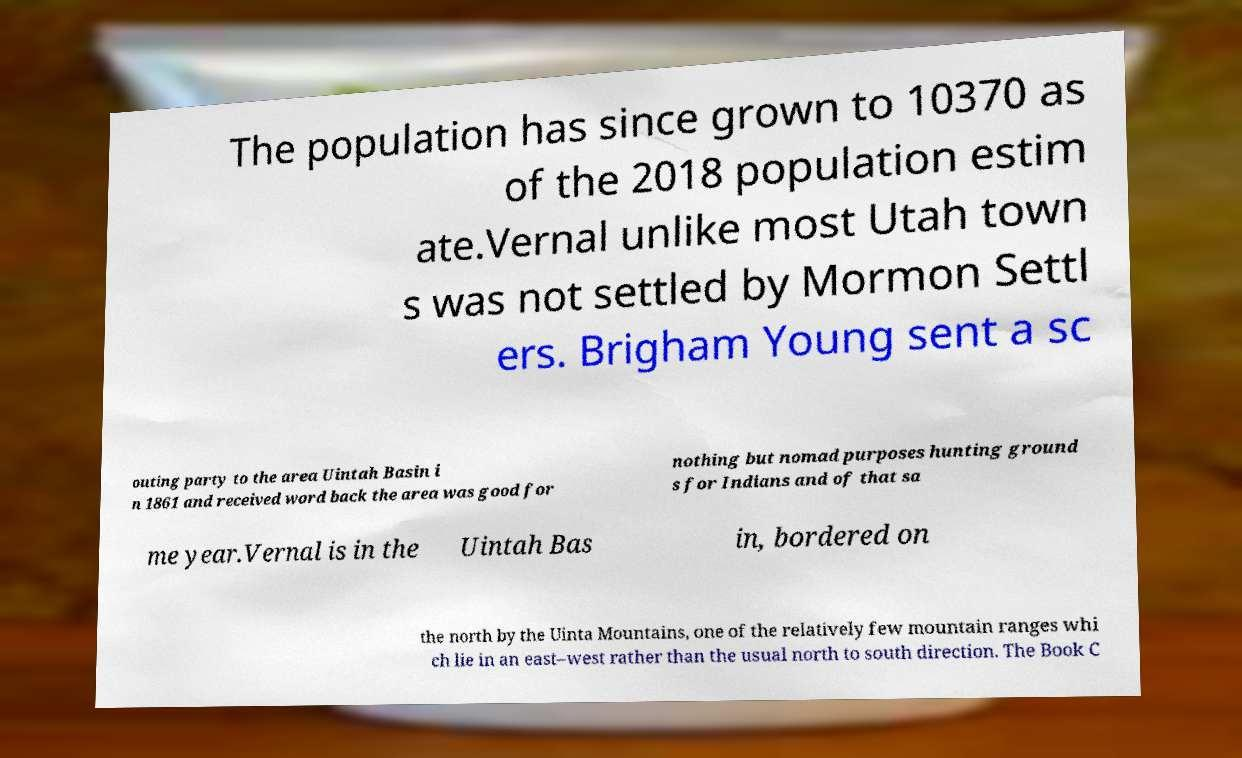Could you assist in decoding the text presented in this image and type it out clearly? The population has since grown to 10370 as of the 2018 population estim ate.Vernal unlike most Utah town s was not settled by Mormon Settl ers. Brigham Young sent a sc outing party to the area Uintah Basin i n 1861 and received word back the area was good for nothing but nomad purposes hunting ground s for Indians and of that sa me year.Vernal is in the Uintah Bas in, bordered on the north by the Uinta Mountains, one of the relatively few mountain ranges whi ch lie in an east–west rather than the usual north to south direction. The Book C 